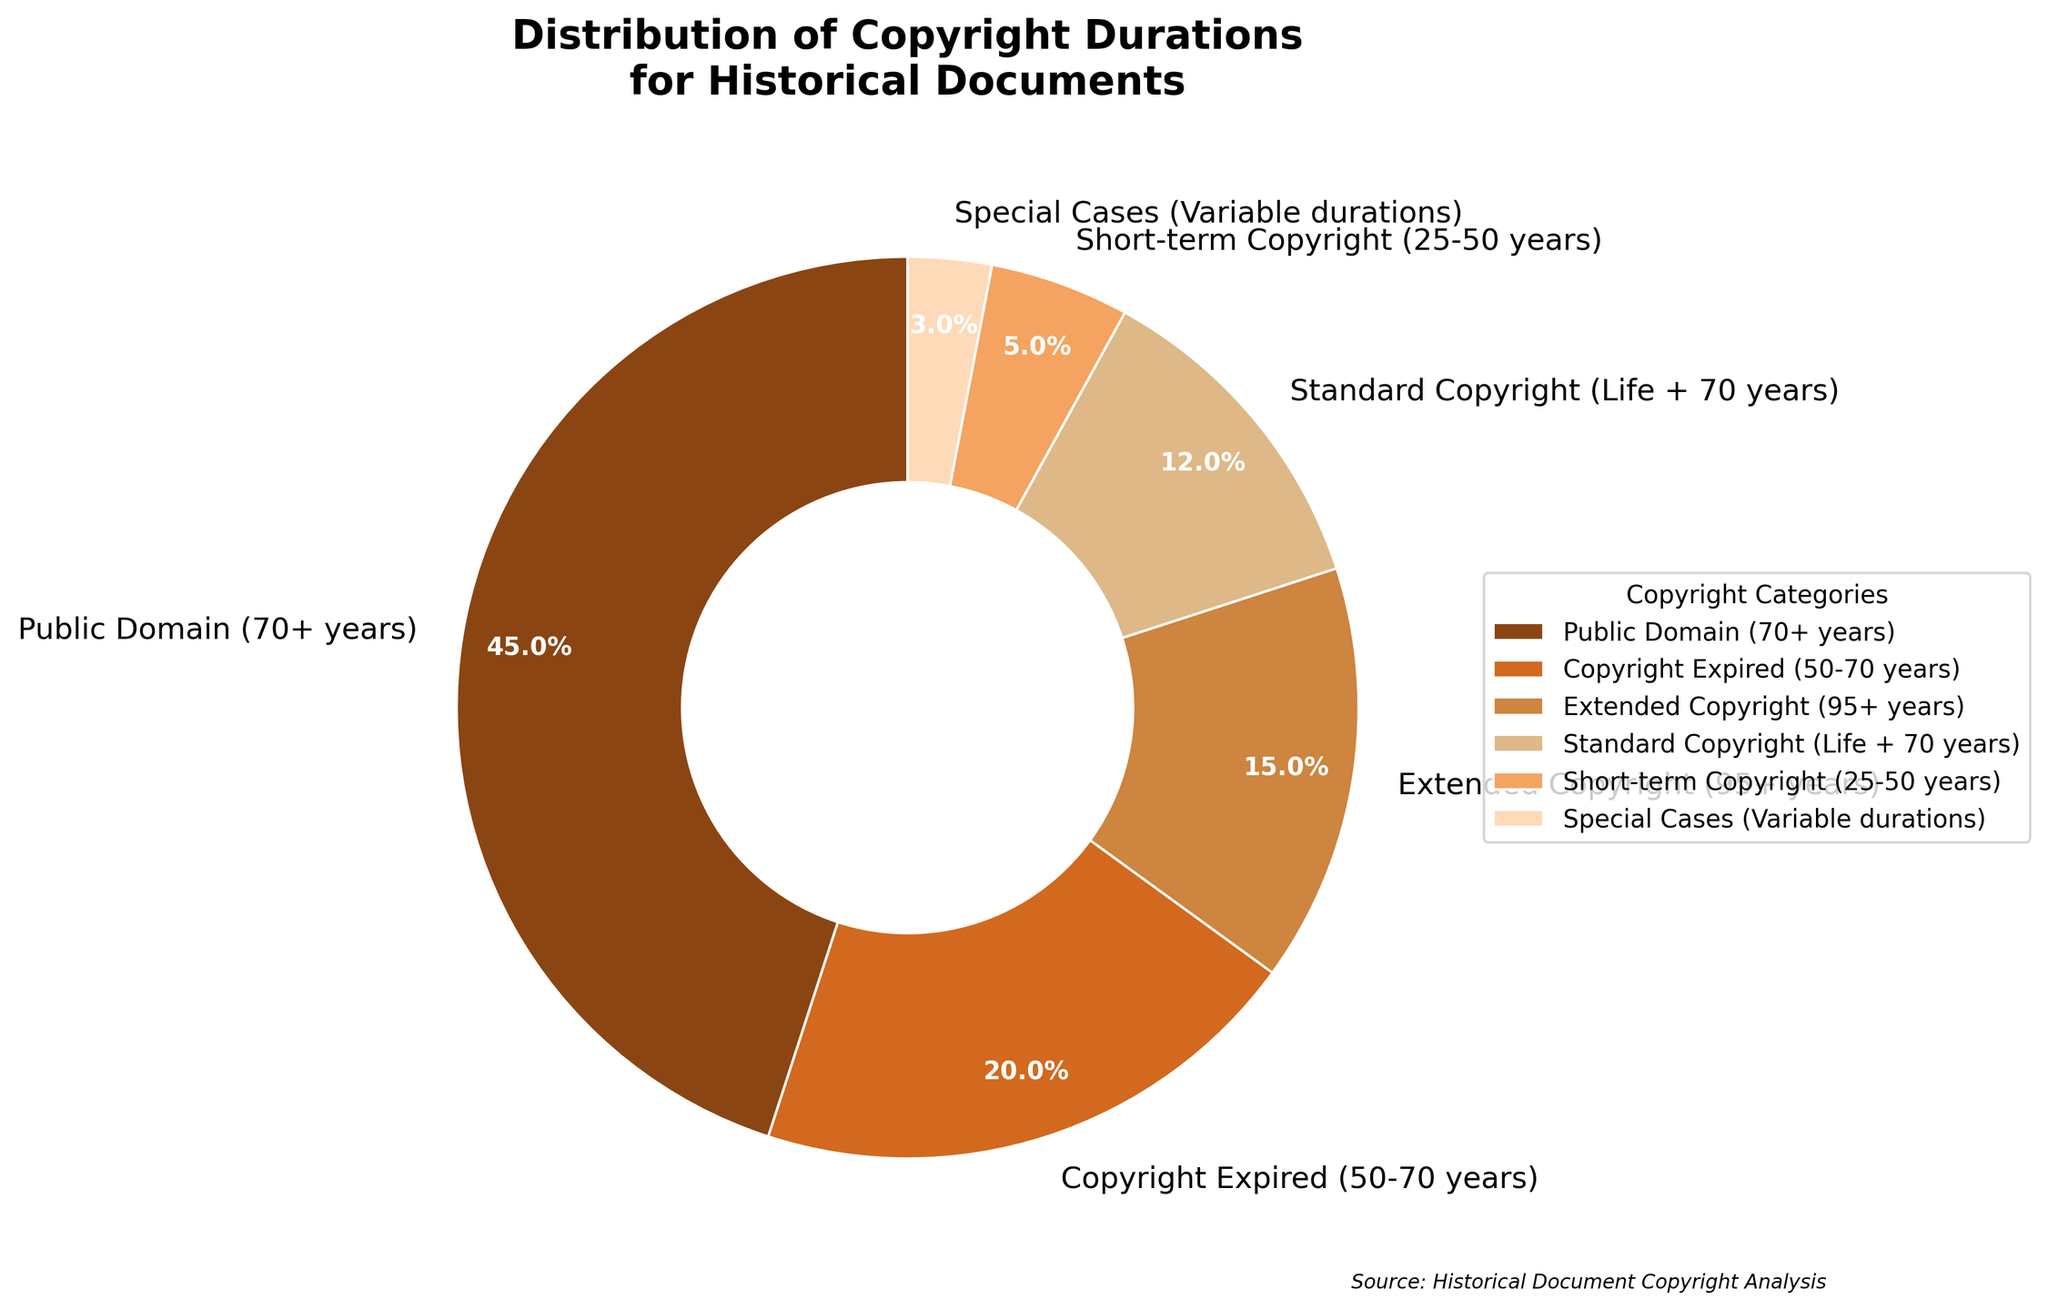What's the largest category in the distribution? The largest category is identified by observing the segment taking up the most space in the pie chart and confirmed by the percentage label. Here, "Public Domain (70+ years)" occupies the biggest segment with 45%.
Answer: Public Domain (70+ years) Which category has the smallest share? The smallest category is the one with the smallest segment in the pie chart and the lowest percentage label. "Special Cases (Variable durations)" is the smallest with 3%.
Answer: Special Cases (Variable durations) How does the share of "Extended Copyright (95+ years)" compare to "Standard Copyright (Life + 70 years)"? By comparing the percentage labels, "Extended Copyright (95+ years)" is 15% while "Standard Copyright (Life + 70 years)" is 12%. Thus, "Extended Copyright (95+ years)" has a larger share.
Answer: Extended Copyright (95+ years) > Standard Copyright (Life + 70 years) What is the combined percentage of "Short-term Copyright (25-50 years)" and "Special Cases (Variable durations)"? Adding the percentages of "Short-term Copyright (25-50 years)" (5%) and "Special Cases (Variable durations)" (3%), we get 5% + 3% = 8%.
Answer: 8% If one wanted to estimate the sum of the three largest categories, which categories should be included and what would their total percentage be? The three largest categories based on percentages are "Public Domain (70+ years)" (45%), "Copyright Expired (50-70 years)" (20%), and "Extended Copyright (95+ years)" (15%). Their total percentage is 45% + 20% + 15% = 80%.
Answer: Public Domain (70+ years), Copyright Expired (50-70 years), Extended Copyright (95+ years), 80% Is the share of "Copyright Expired (50-70 years)" more than twice the share of "Short-term Copyright (25-50 years)"? "Copyright Expired (50-70 years)" is 20%, and "Short-term Copyright (25-50 years)" is 5%. Twice of 5% is 10%, and 20% is more than 10%.
Answer: Yes What color represents the “Extended Copyright (95+ years)” segment? The "Extended Copyright (95+ years)" segment is represented by the color third from the start in the custom color list, which is visually the third segment of the pie chart. It’s a brownish/golden color in the chart.
Answer: Brownish/Golden Compare the combined percentages of “Standard Copyright (Life + 70 years)” and “Special Cases (Variable durations)” to the "Public Domain (70+ years)" category. Which is larger? Adding "Standard Copyright (Life + 70 years)" (12%) and "Special Cases (Variable durations)" (3%), gives 12% + 3% = 15%. "Public Domain (70+ years)" is 45%, which is clearly larger than 15%.
Answer: Public Domain (70+ years) is larger 